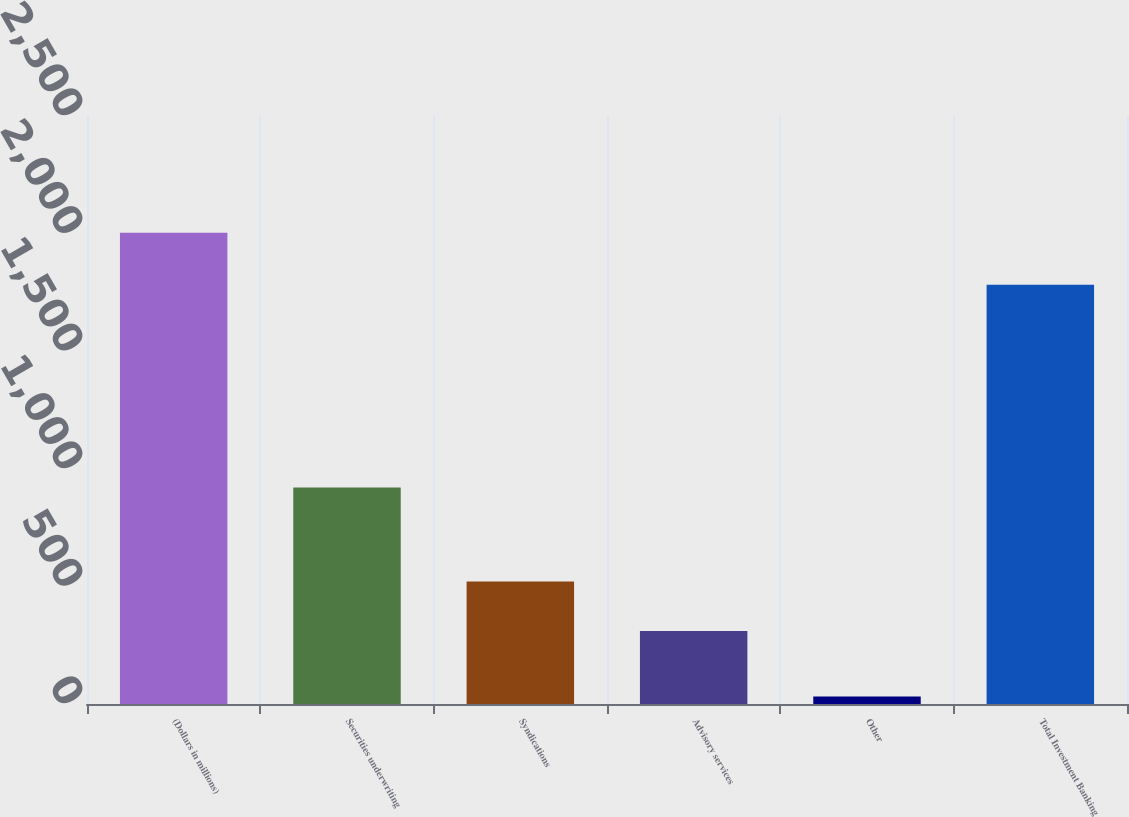Convert chart to OTSL. <chart><loc_0><loc_0><loc_500><loc_500><bar_chart><fcel>(Dollars in millions)<fcel>Securities underwriting<fcel>Syndications<fcel>Advisory services<fcel>Other<fcel>Total Investment Banking<nl><fcel>2004<fcel>920<fcel>521<fcel>310<fcel>32<fcel>1783<nl></chart> 